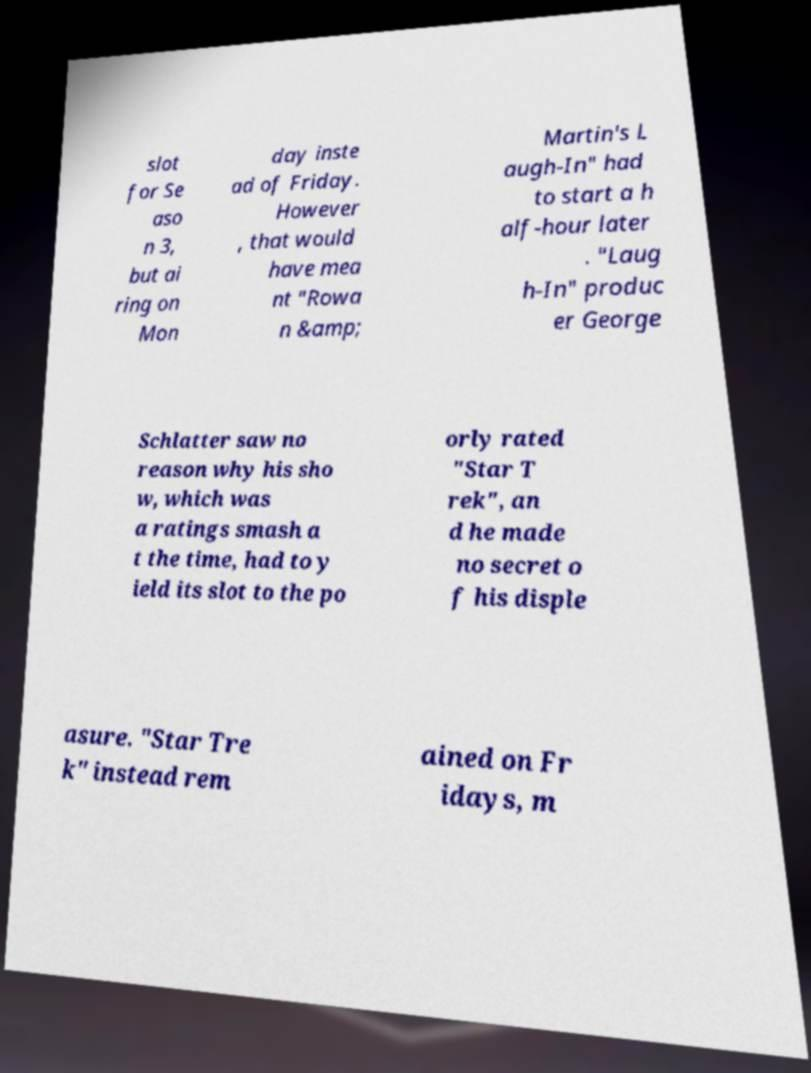Could you assist in decoding the text presented in this image and type it out clearly? slot for Se aso n 3, but ai ring on Mon day inste ad of Friday. However , that would have mea nt "Rowa n &amp; Martin's L augh-In" had to start a h alf-hour later . "Laug h-In" produc er George Schlatter saw no reason why his sho w, which was a ratings smash a t the time, had to y ield its slot to the po orly rated "Star T rek", an d he made no secret o f his disple asure. "Star Tre k" instead rem ained on Fr idays, m 